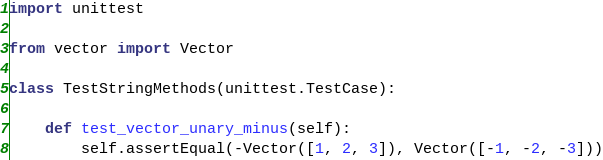<code> <loc_0><loc_0><loc_500><loc_500><_Python_>import unittest

from vector import Vector

class TestStringMethods(unittest.TestCase):

    def test_vector_unary_minus(self):
        self.assertEqual(-Vector([1, 2, 3]), Vector([-1, -2, -3]))
</code> 